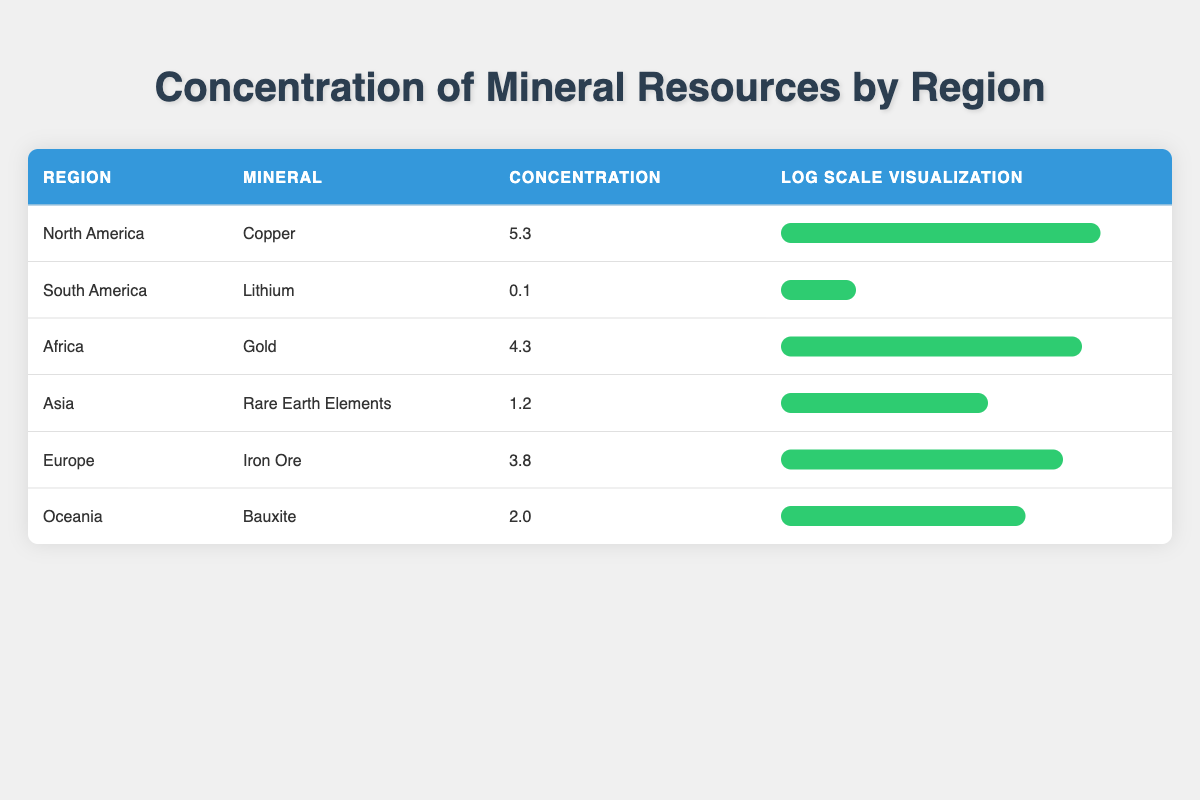What is the concentration of Copper in North America? The table clearly states that the concentration of Copper in North America is listed under the "Concentration" column next to the corresponding region. The value is 5.3.
Answer: 5.3 Which region has the lowest concentration of mineral resources? To determine the region with the lowest concentration, we compare all values in the "Concentration" column. The lowest value is 0.1, which corresponds to South America for Lithium.
Answer: South America What is the average concentration of minerals in Africa and Asia? First, identify the concentrations for Africa and Asia, which are 4.3 (Africa) and 1.2 (Asia). Next, calculate the average: (4.3 + 1.2) / 2 = 5.5 / 2 = 2.75.
Answer: 2.75 Is the concentration of Iron Ore in Europe greater than 2.0? Checking the "Concentration" value for Iron Ore in Europe shows it is 3.8, which is indeed greater than 2.0.
Answer: Yes What is the difference in concentration between Gold in Africa and Iron Ore in Europe? The concentration of Gold is 4.3 (Africa) and Iron Ore is 3.8 (Europe). The difference is calculated as 4.3 - 3.8 = 0.5.
Answer: 0.5 Which mineral has a concentration closer to the average of all minerals listed? First, we calculate the average concentration of all minerals. The total concentrations are 5.3 + 0.1 + 4.3 + 1.2 + 3.8 + 2.0 = 16.7, and there are 6 regions, resulting in an average of 16.7 / 6 ≈ 2.78. The mineral closest to this average is Bauxite in Oceania, with a concentration of 2.0, also is close to 1.2 in Asia.
Answer: Bauxite and Rare Earth Elements How many regions have a mineral concentration greater than 3? By reviewing the "Concentration" column, we find that North America (5.3), Africa (4.3), and Europe (3.8) all have concentrations greater than 3. This gives us a total of 3 regions.
Answer: 3 Is the concentration of Lithium in South America higher than that of Bauxite in Oceania? The concentration of Lithium is shown as 0.1, while the concentration of Bauxite is 2.0. Comparing these values shows that 0.1 is less than 2.0, so it is false that Lithium is higher.
Answer: No Which mineral has the highest concentration and which region does it belong to? By examining the "Concentration" values, Copper at 5.3 in North America is the highest among all.
Answer: Copper, North America 